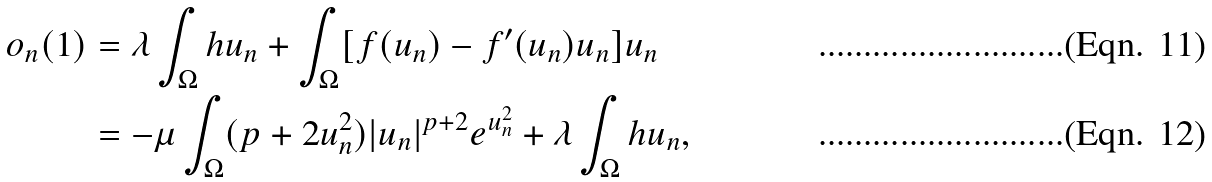Convert formula to latex. <formula><loc_0><loc_0><loc_500><loc_500>o _ { n } ( 1 ) & = \lambda \int _ { \Omega } h u _ { n } + \int _ { \Omega } [ f ( u _ { n } ) - f ^ { \prime } ( u _ { n } ) u _ { n } ] u _ { n } \\ & = - \mu \int _ { \Omega } ( p + 2 u _ { n } ^ { 2 } ) | u _ { n } | ^ { p + 2 } e ^ { u _ { n } ^ { 2 } } + \lambda \int _ { \Omega } h u _ { n } ,</formula> 